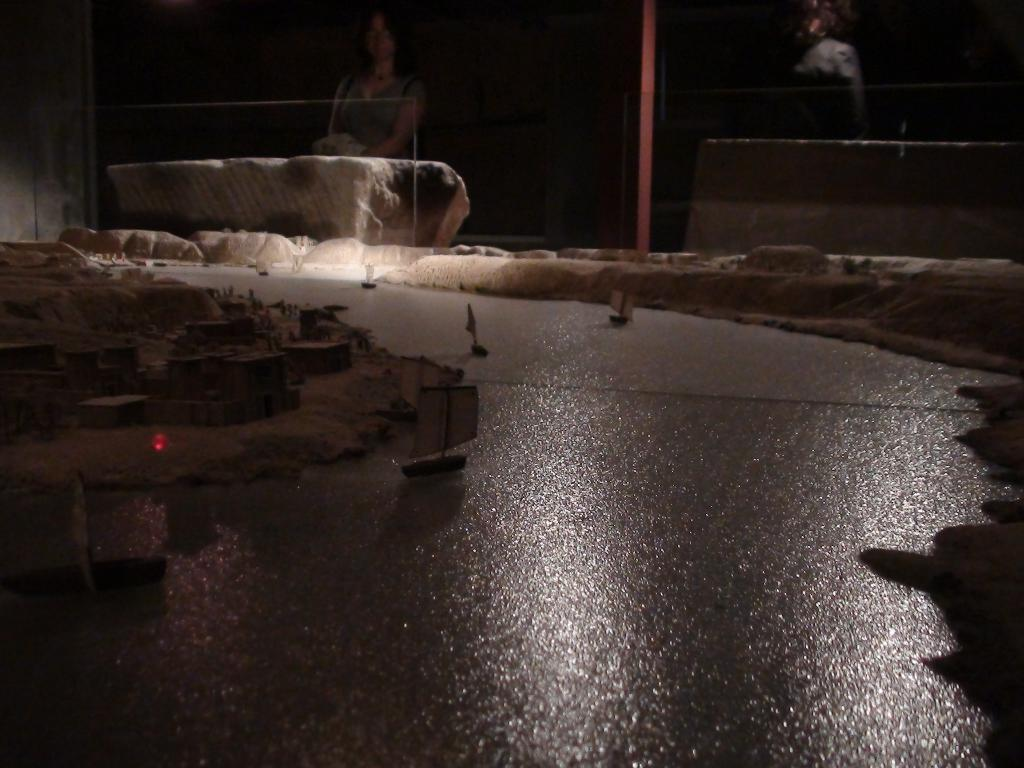What is on the water in the image? There are boats on the water in the image. What is on the land in the image? There are houses on the land in the image. Can you describe the person in the image? There is a person standing on the backside of the image. What type of horse can be seen grazing near the scarecrow in the image? There is no horse or scarecrow present in the image; it features boats on the water and houses on the land. 